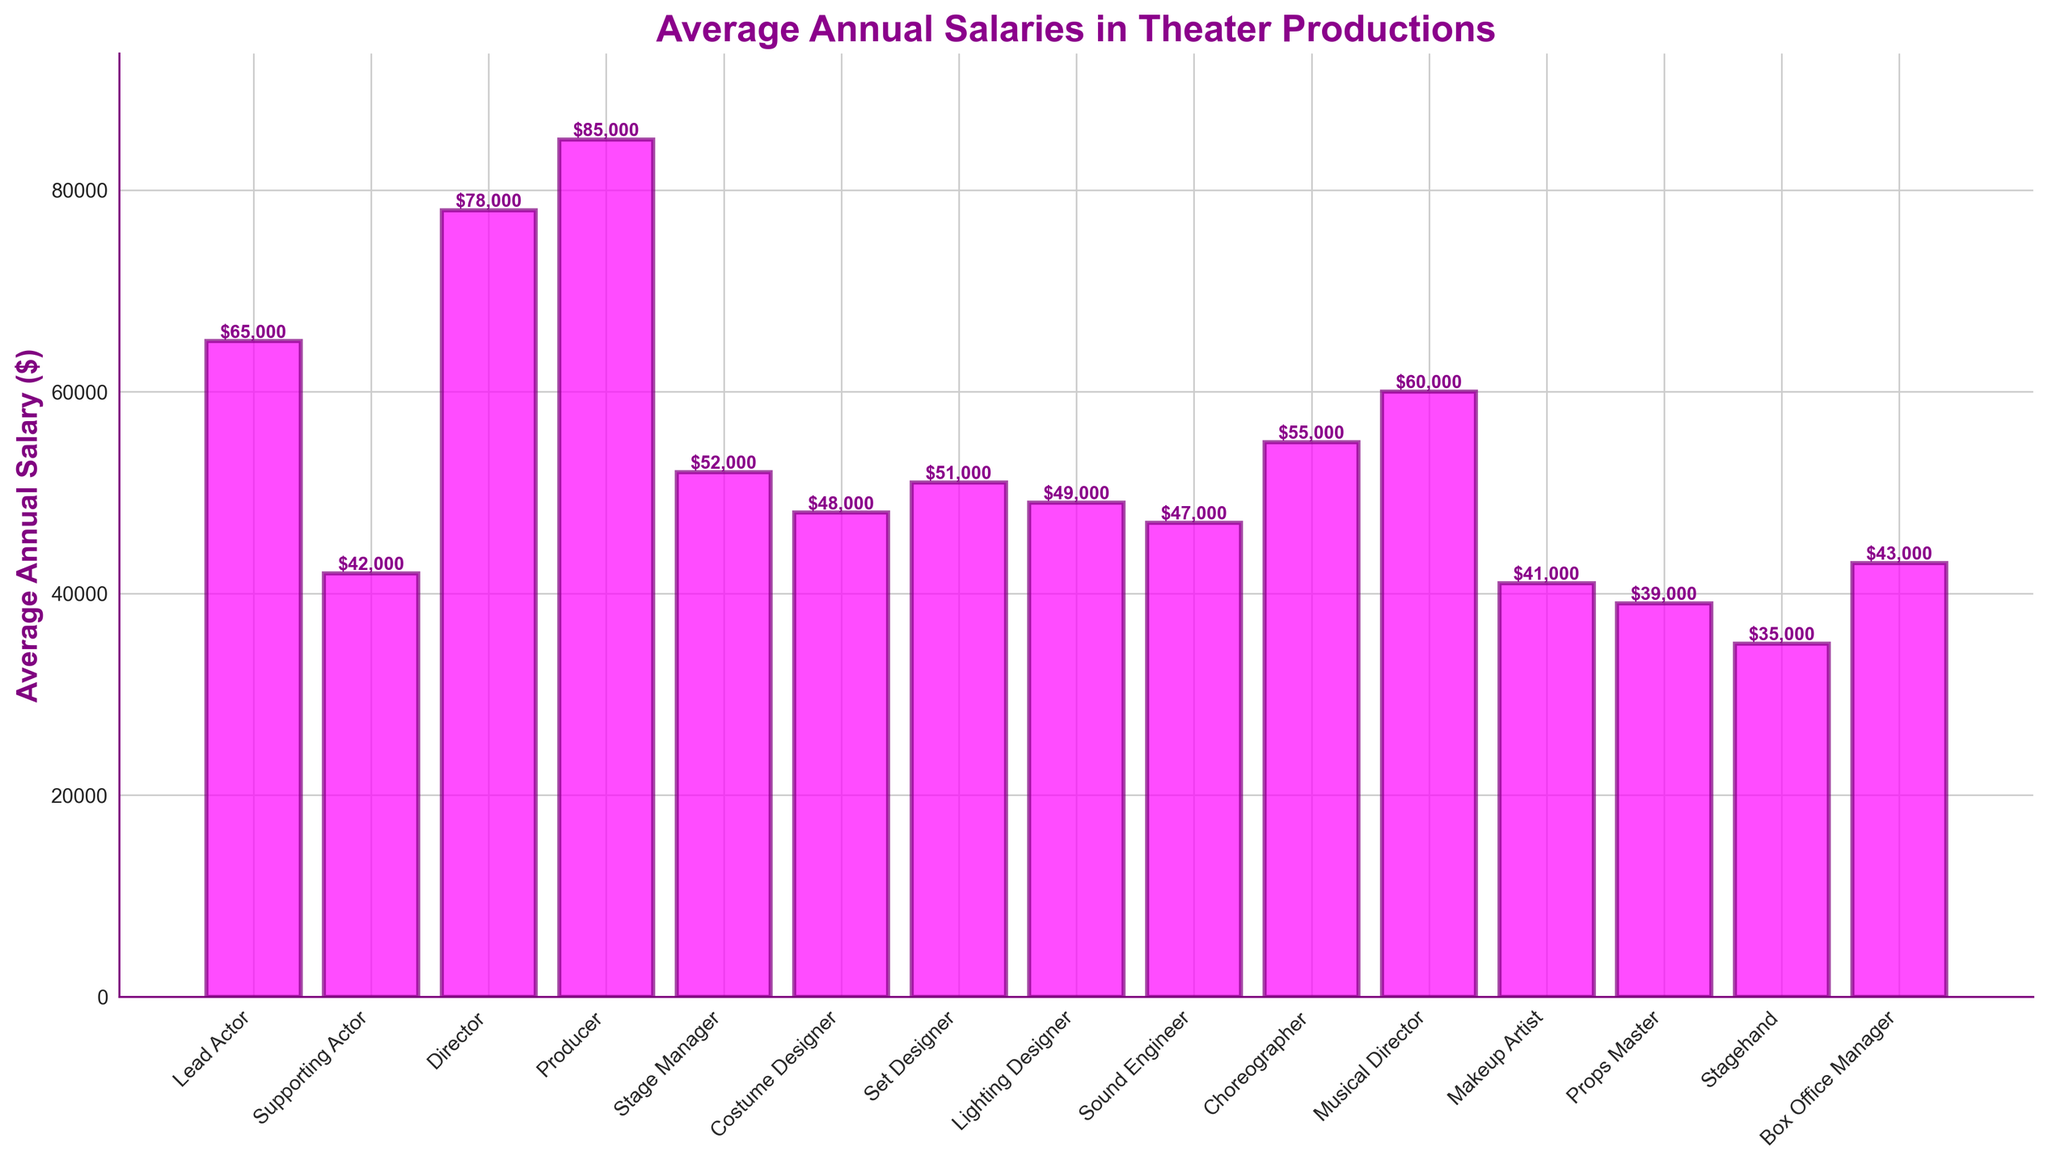What role has the highest average annual salary? The role with the highest bar indicates it has the highest average annual salary. In this case, the Producer has the tallest bar.
Answer: Producer What is the difference in average annual salary between the Lead Actor and the Supporting Actor? Subtract the average annual salary of the Supporting Actor from that of the Lead Actor. $65,000 - $42,000 = $23,000.
Answer: $23,000 Which roles have an average annual salary greater than $50,000 but less than $60,000? Identify the bars between the $50,000 and $60,000 mark. These roles are Stage Manager, Choreographer, and Musical Director.
Answer: Stage Manager, Choreographer, Musical Director If you sum the average annual salaries of the Costume Designer, Set Designer, and Lighting Designer, what is the total? Add the average annual salaries of these roles: $48,000 + $51,000 + $49,000 = $148,000.
Answer: $148,000 Which role has the lowest average annual salary? The role with the shortest bar on the chart has the lowest average annual salary. This is the Stagehand with $35,000.
Answer: Stagehand What is the combined average annual salary of the Director and the Producer? Add the average annual salaries of Director and Producer: $78,000 + $85,000 = $163,000.
Answer: $163,000 How does the average annual salary of a Musical Director compare to that of a Lead Actor? Compare the heights of the bars for the Musical Director and the Lead Actor. The bar for the Lead Actor is higher, indicating a higher salary.
Answer: Lower What is the average salary of all roles depicted in the chart? Sum all the average annual salaries and divide by the number of roles. ($65,000 + $42,000 + $78,000 + $85,000 + $52,000 + $48,000 + $51,000 + $49,000 + $47,000 + $55,000 + $60,000 + $41,000 + $39,000 + $35,000 + $43,000) / 15 = $53,267.
Answer: $53,267 Among the roles listed, which one has a salary closest to the median of all these salaries? To find the median salary, first list all salaries in ascending order and find the middle value. The roles with their salaries are: Stagehand ($35,000), Props Master ($39,000), Makeup Artist ($41,000), Supporting Actor ($42,000), Box Office Manager ($43,000), Sound Engineer ($47,000), Costume Designer ($48,000), Lighting Designer ($49,000), Set Designer ($51,000), Stage Manager ($52,000), Choreographer ($55,000), Musical Director ($60,000), Lead Actor ($65,000), Director ($78,000), Producer ($85,000). The median salary is the 8th value which is $49,000 (Lighting Designer).
Answer: Lighting Designer What is the proportional difference in average annual salary between a Stagehand and a Producer? Divide the salary of the Stagehand by the salary of the Producer and subtract from 1: 1 - ($35,000 / $85,000) = 1 - 0.4118 ≈ 0.5882, or 58.82%.
Answer: 58.82% 